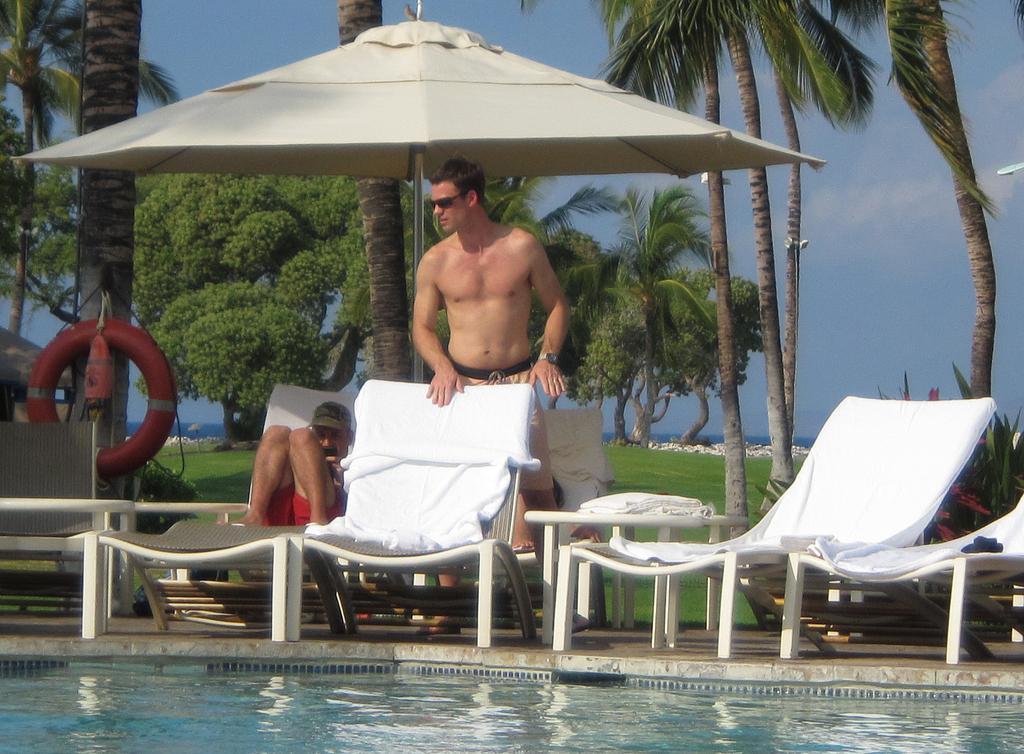Describe this image in one or two sentences. a person is standing in front a chair. behind him there is another person sitting. at the back there are trees. in the front there is water in the pool. 